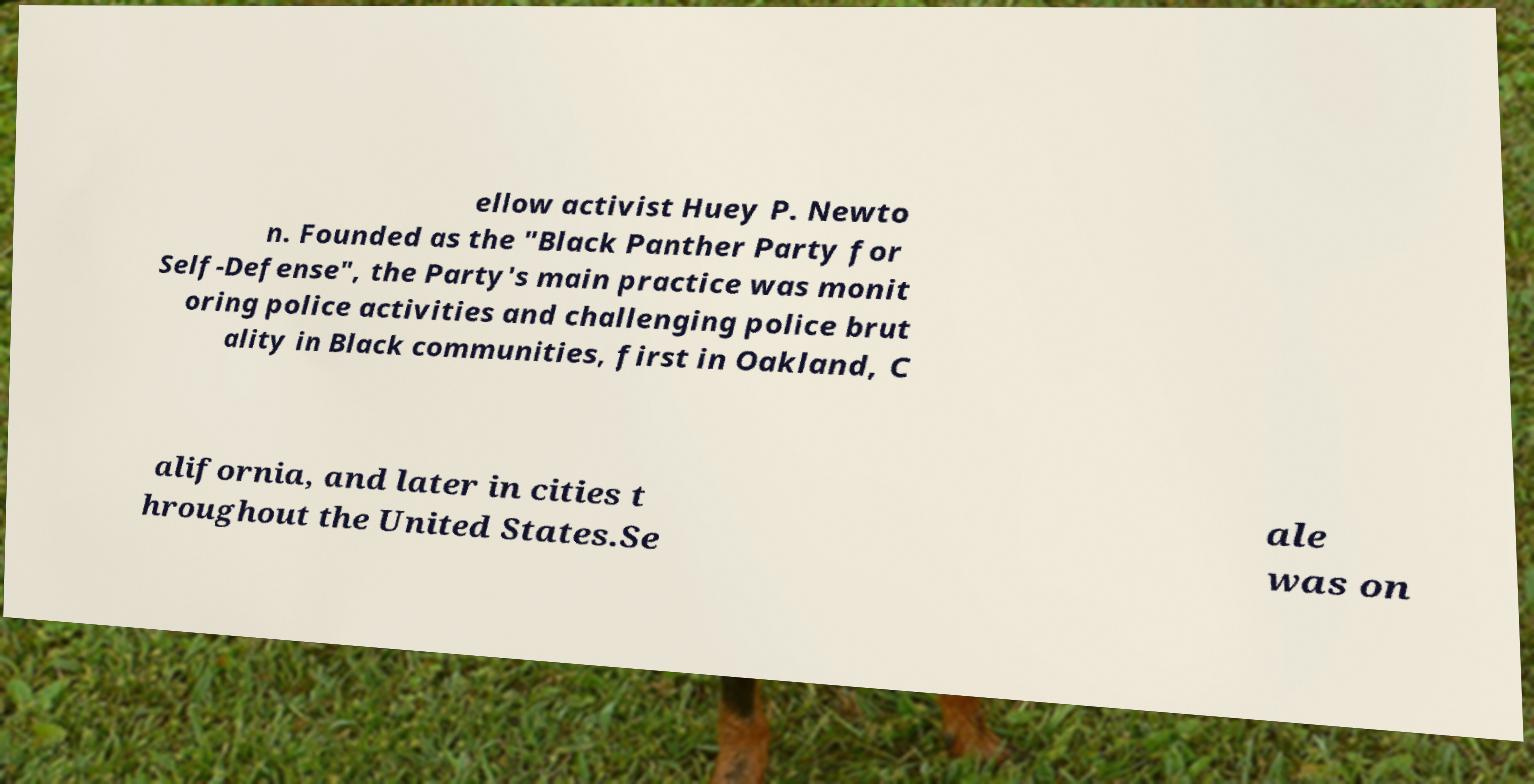Could you extract and type out the text from this image? ellow activist Huey P. Newto n. Founded as the "Black Panther Party for Self-Defense", the Party's main practice was monit oring police activities and challenging police brut ality in Black communities, first in Oakland, C alifornia, and later in cities t hroughout the United States.Se ale was on 